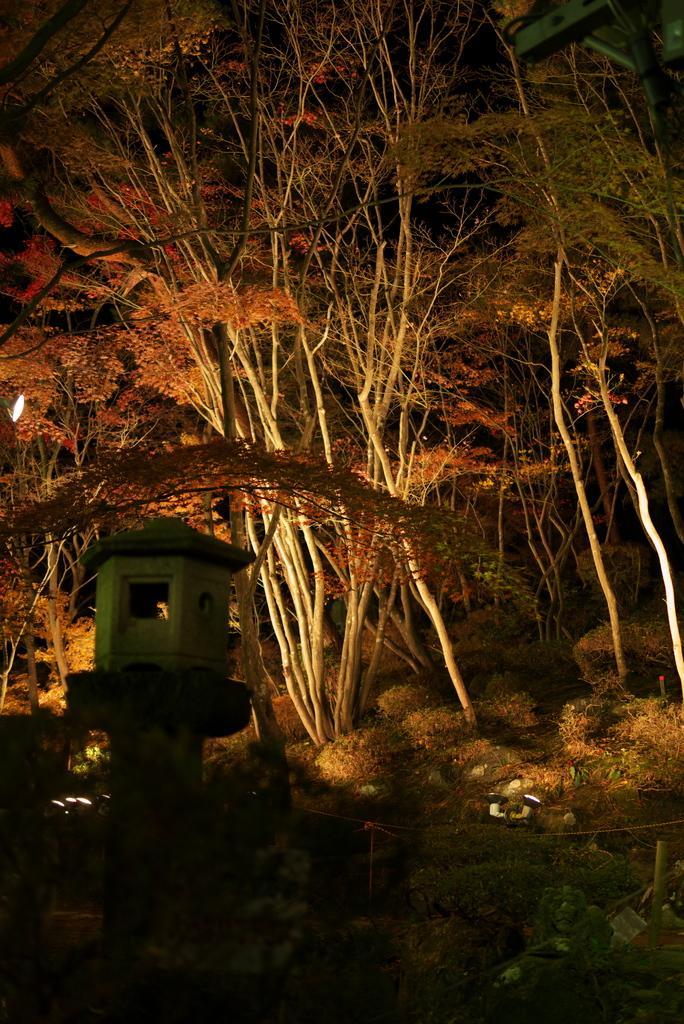Describe this image in one or two sentences. In this picture I can observe plants and trees on the land. On the left side there is a light. The background is dark. 